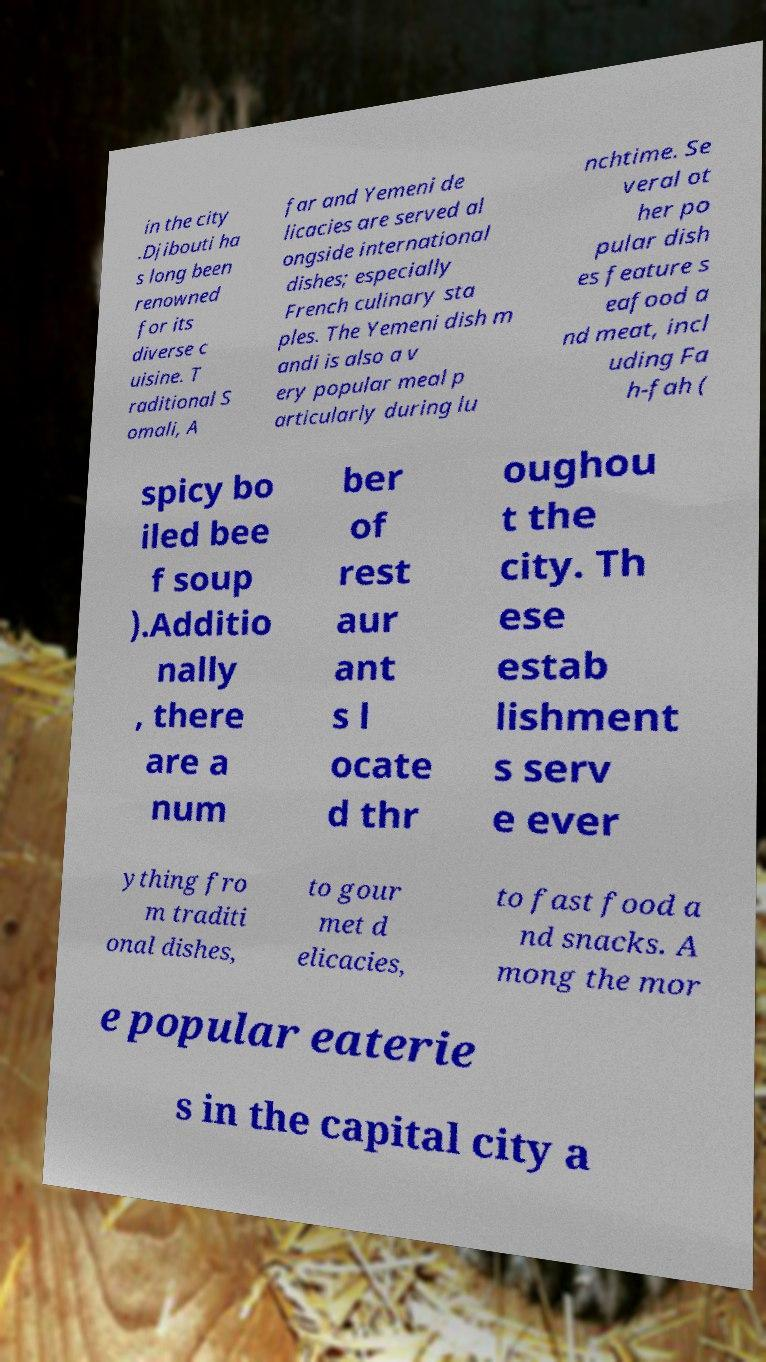Can you accurately transcribe the text from the provided image for me? in the city .Djibouti ha s long been renowned for its diverse c uisine. T raditional S omali, A far and Yemeni de licacies are served al ongside international dishes; especially French culinary sta ples. The Yemeni dish m andi is also a v ery popular meal p articularly during lu nchtime. Se veral ot her po pular dish es feature s eafood a nd meat, incl uding Fa h-fah ( spicy bo iled bee f soup ).Additio nally , there are a num ber of rest aur ant s l ocate d thr oughou t the city. Th ese estab lishment s serv e ever ything fro m traditi onal dishes, to gour met d elicacies, to fast food a nd snacks. A mong the mor e popular eaterie s in the capital city a 